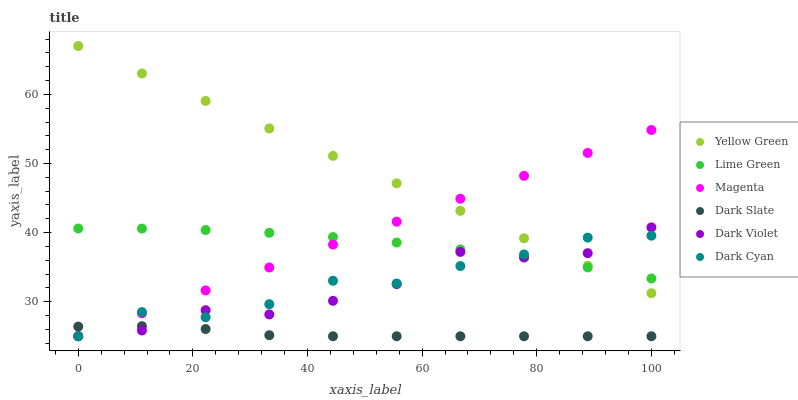Does Dark Slate have the minimum area under the curve?
Answer yes or no. Yes. Does Yellow Green have the maximum area under the curve?
Answer yes or no. Yes. Does Dark Violet have the minimum area under the curve?
Answer yes or no. No. Does Dark Violet have the maximum area under the curve?
Answer yes or no. No. Is Yellow Green the smoothest?
Answer yes or no. Yes. Is Dark Violet the roughest?
Answer yes or no. Yes. Is Dark Slate the smoothest?
Answer yes or no. No. Is Dark Slate the roughest?
Answer yes or no. No. Does Dark Violet have the lowest value?
Answer yes or no. Yes. Does Lime Green have the lowest value?
Answer yes or no. No. Does Yellow Green have the highest value?
Answer yes or no. Yes. Does Dark Violet have the highest value?
Answer yes or no. No. Is Dark Slate less than Yellow Green?
Answer yes or no. Yes. Is Yellow Green greater than Dark Slate?
Answer yes or no. Yes. Does Dark Cyan intersect Dark Slate?
Answer yes or no. Yes. Is Dark Cyan less than Dark Slate?
Answer yes or no. No. Is Dark Cyan greater than Dark Slate?
Answer yes or no. No. Does Dark Slate intersect Yellow Green?
Answer yes or no. No. 